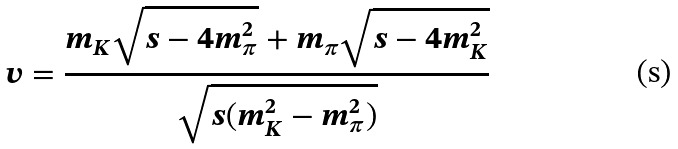Convert formula to latex. <formula><loc_0><loc_0><loc_500><loc_500>v = \frac { m _ { K } \sqrt { s - 4 m _ { \pi } ^ { 2 } } + m _ { \pi } \sqrt { s - 4 m _ { K } ^ { 2 } } } { \sqrt { s ( m _ { K } ^ { 2 } - m _ { \pi } ^ { 2 } ) } }</formula> 